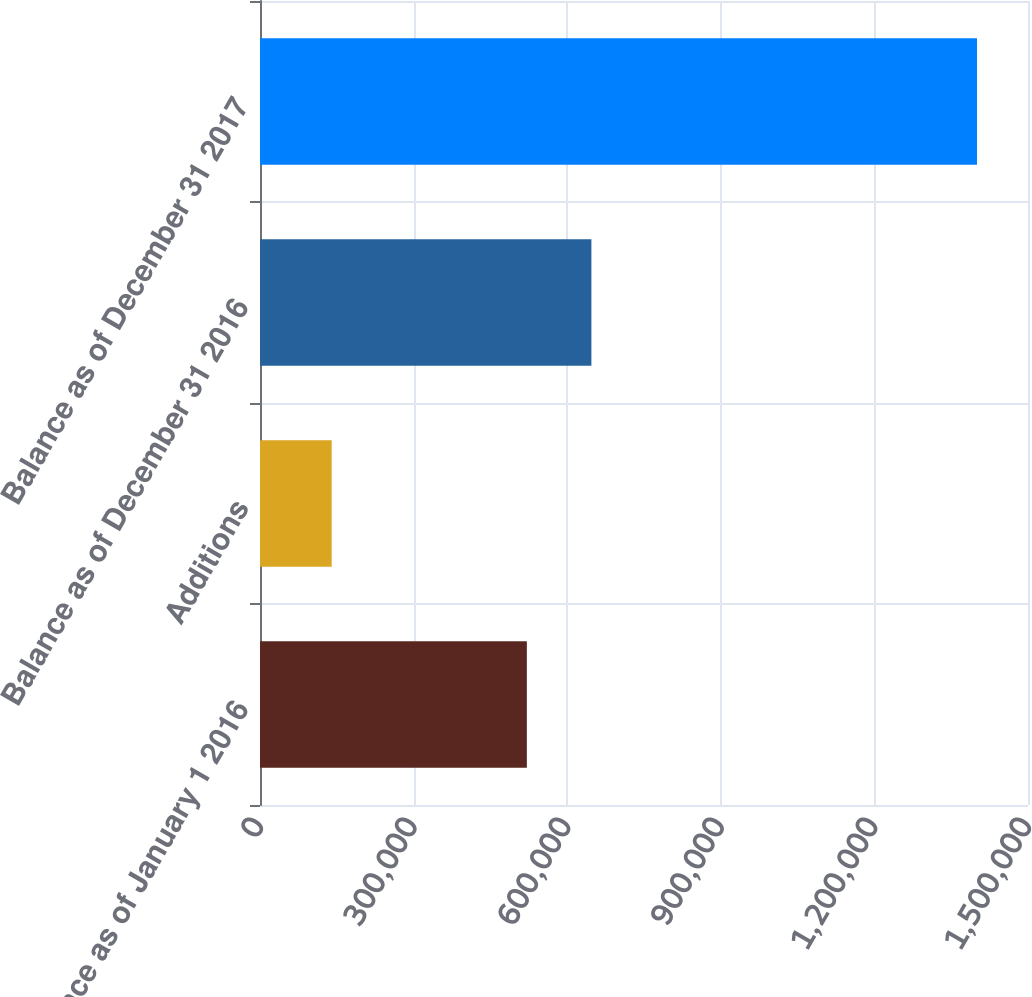Convert chart to OTSL. <chart><loc_0><loc_0><loc_500><loc_500><bar_chart><fcel>Balance as of January 1 2016<fcel>Additions<fcel>Balance as of December 31 2016<fcel>Balance as of December 31 2017<nl><fcel>521213<fcel>139982<fcel>647254<fcel>1.40039e+06<nl></chart> 